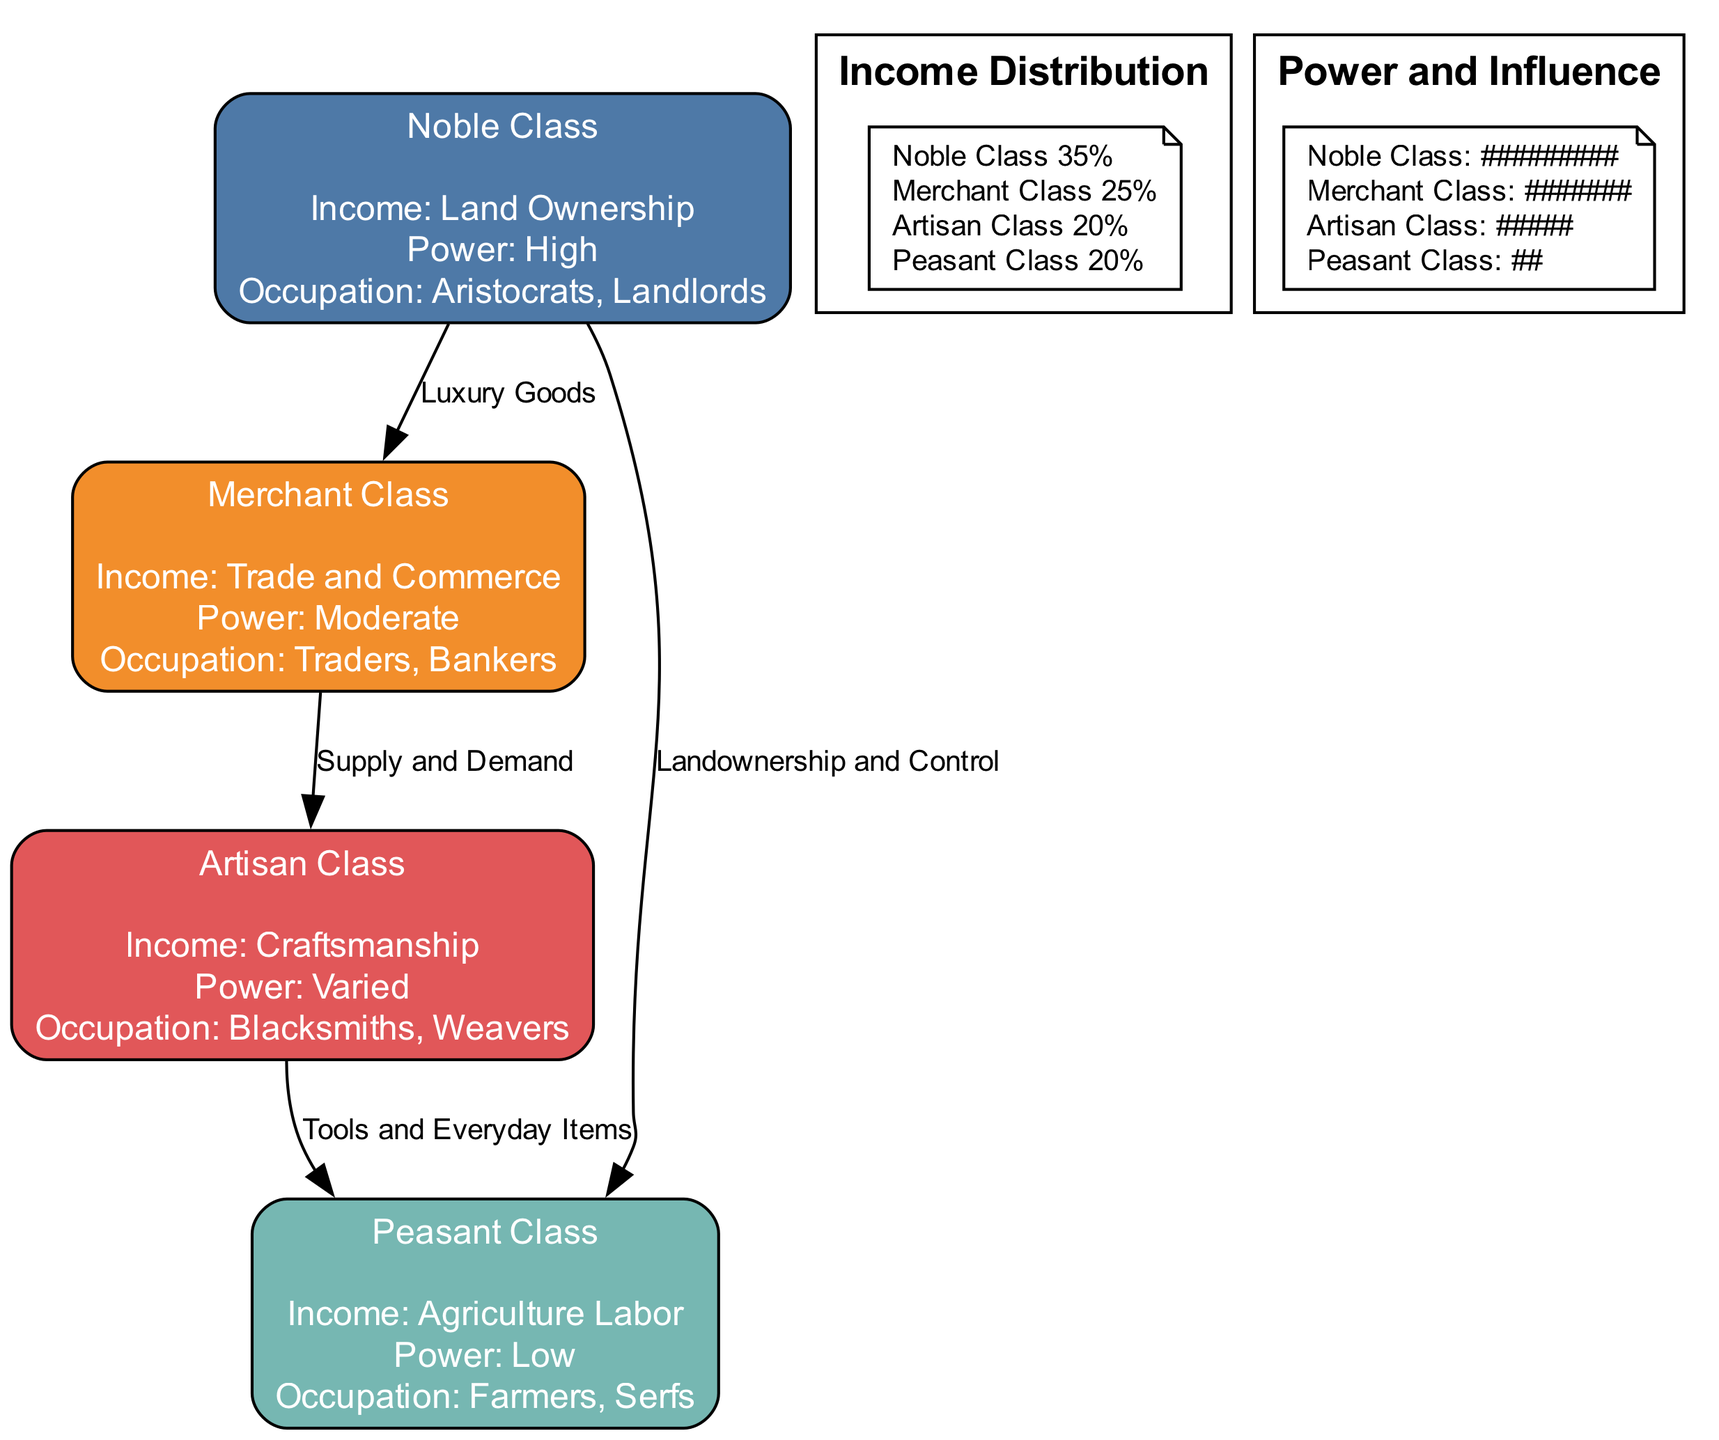What is the income source of the Noble Class? The diagram states that the income source for the Noble Class is "Land Ownership." This information is displayed directly under the label for the Noble Class, indicating their primary means of generating income.
Answer: Land Ownership How many socio-economic classes are represented in the diagram? By counting the nodes listed in the diagram, we find a total of four socio-economic classes: Noble Class, Merchant Class, Artisan Class, and Peasant Class. Thus, the total number of classes is four.
Answer: 4 Which class has the highest power influence? The Power and Influence chart indicates that the Noble Class has the highest value, represented as 90 in the bar chart. This is the highest numerical value among all the classes, showcasing their significant influence.
Answer: Noble Class What is the relationship between the Merchant Class and the Artisan Class? The diagram shows an edge labeled "Supply and Demand" connecting the Merchant Class to the Artisan Class. This indicates a relationship where the Merchant Class likely relies on the Artisan Class for the production of goods that will be traded.
Answer: Supply and Demand What percentage of income does the Artisan Class account for? The pie chart illustrates that the Artisan Class accounts for 20% of the income distribution depicted in the diagram. This value is represented as a slice of the pie designated for this class.
Answer: 20% Which class showed an increase in population over time? Referring to the Population Over Time line chart, the Merchant Class shows consistent growth in population, with values rising from 30 to 49 over the observed years. This indicates that their population increased during the period analyzed.
Answer: Merchant Class How does the income percentage of the Peasant Class compare to the Noble Class? The income percentage for the Peasant Class is 20%, while for the Noble Class, it is 35%. Thus, the Noble Class has a higher income percentage compared to the Peasant Class, showing a significant disparity in wealth.
Answer: Noble Class is higher What does the edge between the Noble Class and Peasant Class represent? The edge labeled "Landownership and Control" connecting these two classes represents the relationship where the Noble Class holds land and thus has control over the Peasant Class, who work the land. This illustrates the hierarchy and power dynamics between these classes.
Answer: Landownership and Control What is represented on the y-axis of the population chart? The y-axis of the Population Over Time chart is labeled "Population (in thousands)," indicating that the numerical values represented are with respect to the population counts of each class measured in thousands.
Answer: Population (in thousands) 